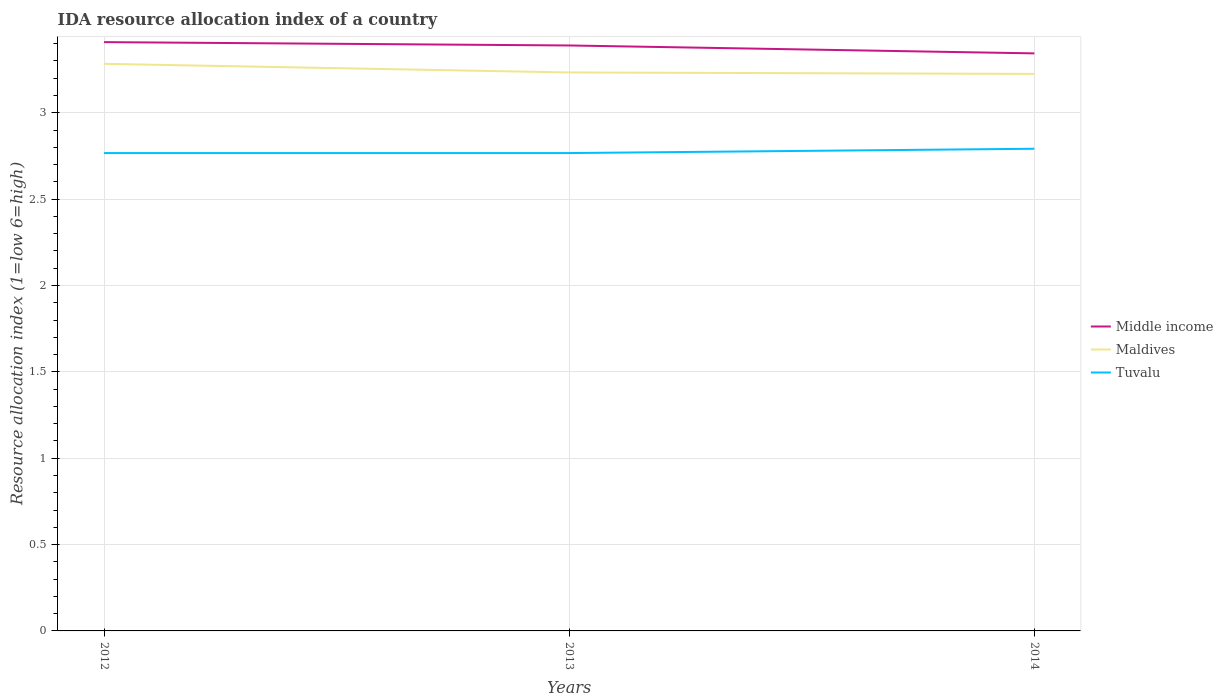How many different coloured lines are there?
Offer a terse response. 3. Across all years, what is the maximum IDA resource allocation index in Tuvalu?
Make the answer very short. 2.77. In which year was the IDA resource allocation index in Maldives maximum?
Offer a very short reply. 2014. What is the total IDA resource allocation index in Maldives in the graph?
Your response must be concise. 0.01. What is the difference between the highest and the second highest IDA resource allocation index in Maldives?
Give a very brief answer. 0.06. How many lines are there?
Your response must be concise. 3. How many years are there in the graph?
Offer a very short reply. 3. What is the difference between two consecutive major ticks on the Y-axis?
Ensure brevity in your answer.  0.5. Are the values on the major ticks of Y-axis written in scientific E-notation?
Your answer should be very brief. No. Does the graph contain any zero values?
Keep it short and to the point. No. Where does the legend appear in the graph?
Keep it short and to the point. Center right. What is the title of the graph?
Your answer should be very brief. IDA resource allocation index of a country. What is the label or title of the Y-axis?
Your answer should be compact. Resource allocation index (1=low 6=high). What is the Resource allocation index (1=low 6=high) in Middle income in 2012?
Your answer should be compact. 3.41. What is the Resource allocation index (1=low 6=high) in Maldives in 2012?
Ensure brevity in your answer.  3.28. What is the Resource allocation index (1=low 6=high) of Tuvalu in 2012?
Provide a short and direct response. 2.77. What is the Resource allocation index (1=low 6=high) in Middle income in 2013?
Provide a succinct answer. 3.39. What is the Resource allocation index (1=low 6=high) in Maldives in 2013?
Ensure brevity in your answer.  3.23. What is the Resource allocation index (1=low 6=high) in Tuvalu in 2013?
Keep it short and to the point. 2.77. What is the Resource allocation index (1=low 6=high) in Middle income in 2014?
Give a very brief answer. 3.34. What is the Resource allocation index (1=low 6=high) of Maldives in 2014?
Offer a terse response. 3.23. What is the Resource allocation index (1=low 6=high) of Tuvalu in 2014?
Make the answer very short. 2.79. Across all years, what is the maximum Resource allocation index (1=low 6=high) of Middle income?
Ensure brevity in your answer.  3.41. Across all years, what is the maximum Resource allocation index (1=low 6=high) in Maldives?
Your response must be concise. 3.28. Across all years, what is the maximum Resource allocation index (1=low 6=high) of Tuvalu?
Your answer should be very brief. 2.79. Across all years, what is the minimum Resource allocation index (1=low 6=high) in Middle income?
Give a very brief answer. 3.34. Across all years, what is the minimum Resource allocation index (1=low 6=high) in Maldives?
Offer a terse response. 3.23. Across all years, what is the minimum Resource allocation index (1=low 6=high) in Tuvalu?
Provide a short and direct response. 2.77. What is the total Resource allocation index (1=low 6=high) of Middle income in the graph?
Offer a very short reply. 10.14. What is the total Resource allocation index (1=low 6=high) of Maldives in the graph?
Offer a terse response. 9.74. What is the total Resource allocation index (1=low 6=high) of Tuvalu in the graph?
Ensure brevity in your answer.  8.32. What is the difference between the Resource allocation index (1=low 6=high) of Middle income in 2012 and that in 2013?
Your answer should be compact. 0.02. What is the difference between the Resource allocation index (1=low 6=high) in Maldives in 2012 and that in 2013?
Provide a short and direct response. 0.05. What is the difference between the Resource allocation index (1=low 6=high) of Tuvalu in 2012 and that in 2013?
Offer a terse response. 0. What is the difference between the Resource allocation index (1=low 6=high) of Middle income in 2012 and that in 2014?
Keep it short and to the point. 0.07. What is the difference between the Resource allocation index (1=low 6=high) of Maldives in 2012 and that in 2014?
Offer a very short reply. 0.06. What is the difference between the Resource allocation index (1=low 6=high) in Tuvalu in 2012 and that in 2014?
Provide a succinct answer. -0.03. What is the difference between the Resource allocation index (1=low 6=high) in Middle income in 2013 and that in 2014?
Provide a short and direct response. 0.05. What is the difference between the Resource allocation index (1=low 6=high) of Maldives in 2013 and that in 2014?
Offer a very short reply. 0.01. What is the difference between the Resource allocation index (1=low 6=high) in Tuvalu in 2013 and that in 2014?
Offer a very short reply. -0.03. What is the difference between the Resource allocation index (1=low 6=high) of Middle income in 2012 and the Resource allocation index (1=low 6=high) of Maldives in 2013?
Provide a short and direct response. 0.18. What is the difference between the Resource allocation index (1=low 6=high) in Middle income in 2012 and the Resource allocation index (1=low 6=high) in Tuvalu in 2013?
Provide a short and direct response. 0.64. What is the difference between the Resource allocation index (1=low 6=high) in Maldives in 2012 and the Resource allocation index (1=low 6=high) in Tuvalu in 2013?
Your answer should be compact. 0.52. What is the difference between the Resource allocation index (1=low 6=high) of Middle income in 2012 and the Resource allocation index (1=low 6=high) of Maldives in 2014?
Your answer should be very brief. 0.18. What is the difference between the Resource allocation index (1=low 6=high) in Middle income in 2012 and the Resource allocation index (1=low 6=high) in Tuvalu in 2014?
Keep it short and to the point. 0.62. What is the difference between the Resource allocation index (1=low 6=high) of Maldives in 2012 and the Resource allocation index (1=low 6=high) of Tuvalu in 2014?
Provide a short and direct response. 0.49. What is the difference between the Resource allocation index (1=low 6=high) of Middle income in 2013 and the Resource allocation index (1=low 6=high) of Maldives in 2014?
Ensure brevity in your answer.  0.16. What is the difference between the Resource allocation index (1=low 6=high) in Middle income in 2013 and the Resource allocation index (1=low 6=high) in Tuvalu in 2014?
Your answer should be very brief. 0.6. What is the difference between the Resource allocation index (1=low 6=high) of Maldives in 2013 and the Resource allocation index (1=low 6=high) of Tuvalu in 2014?
Your answer should be very brief. 0.44. What is the average Resource allocation index (1=low 6=high) in Middle income per year?
Provide a succinct answer. 3.38. What is the average Resource allocation index (1=low 6=high) of Maldives per year?
Provide a succinct answer. 3.25. What is the average Resource allocation index (1=low 6=high) of Tuvalu per year?
Your response must be concise. 2.77. In the year 2012, what is the difference between the Resource allocation index (1=low 6=high) of Middle income and Resource allocation index (1=low 6=high) of Maldives?
Your answer should be compact. 0.13. In the year 2012, what is the difference between the Resource allocation index (1=low 6=high) in Middle income and Resource allocation index (1=low 6=high) in Tuvalu?
Keep it short and to the point. 0.64. In the year 2012, what is the difference between the Resource allocation index (1=low 6=high) in Maldives and Resource allocation index (1=low 6=high) in Tuvalu?
Keep it short and to the point. 0.52. In the year 2013, what is the difference between the Resource allocation index (1=low 6=high) in Middle income and Resource allocation index (1=low 6=high) in Maldives?
Keep it short and to the point. 0.16. In the year 2013, what is the difference between the Resource allocation index (1=low 6=high) in Middle income and Resource allocation index (1=low 6=high) in Tuvalu?
Ensure brevity in your answer.  0.62. In the year 2013, what is the difference between the Resource allocation index (1=low 6=high) in Maldives and Resource allocation index (1=low 6=high) in Tuvalu?
Ensure brevity in your answer.  0.47. In the year 2014, what is the difference between the Resource allocation index (1=low 6=high) of Middle income and Resource allocation index (1=low 6=high) of Maldives?
Provide a short and direct response. 0.12. In the year 2014, what is the difference between the Resource allocation index (1=low 6=high) of Middle income and Resource allocation index (1=low 6=high) of Tuvalu?
Keep it short and to the point. 0.55. In the year 2014, what is the difference between the Resource allocation index (1=low 6=high) of Maldives and Resource allocation index (1=low 6=high) of Tuvalu?
Make the answer very short. 0.43. What is the ratio of the Resource allocation index (1=low 6=high) of Maldives in 2012 to that in 2013?
Provide a succinct answer. 1.02. What is the ratio of the Resource allocation index (1=low 6=high) in Tuvalu in 2012 to that in 2013?
Give a very brief answer. 1. What is the ratio of the Resource allocation index (1=low 6=high) of Middle income in 2012 to that in 2014?
Give a very brief answer. 1.02. What is the ratio of the Resource allocation index (1=low 6=high) of Maldives in 2012 to that in 2014?
Keep it short and to the point. 1.02. What is the ratio of the Resource allocation index (1=low 6=high) in Middle income in 2013 to that in 2014?
Your answer should be very brief. 1.01. What is the ratio of the Resource allocation index (1=low 6=high) of Maldives in 2013 to that in 2014?
Your response must be concise. 1. What is the ratio of the Resource allocation index (1=low 6=high) of Tuvalu in 2013 to that in 2014?
Provide a succinct answer. 0.99. What is the difference between the highest and the second highest Resource allocation index (1=low 6=high) of Middle income?
Offer a very short reply. 0.02. What is the difference between the highest and the second highest Resource allocation index (1=low 6=high) of Maldives?
Your answer should be very brief. 0.05. What is the difference between the highest and the second highest Resource allocation index (1=low 6=high) of Tuvalu?
Your answer should be very brief. 0.03. What is the difference between the highest and the lowest Resource allocation index (1=low 6=high) in Middle income?
Provide a short and direct response. 0.07. What is the difference between the highest and the lowest Resource allocation index (1=low 6=high) of Maldives?
Offer a terse response. 0.06. What is the difference between the highest and the lowest Resource allocation index (1=low 6=high) in Tuvalu?
Offer a very short reply. 0.03. 